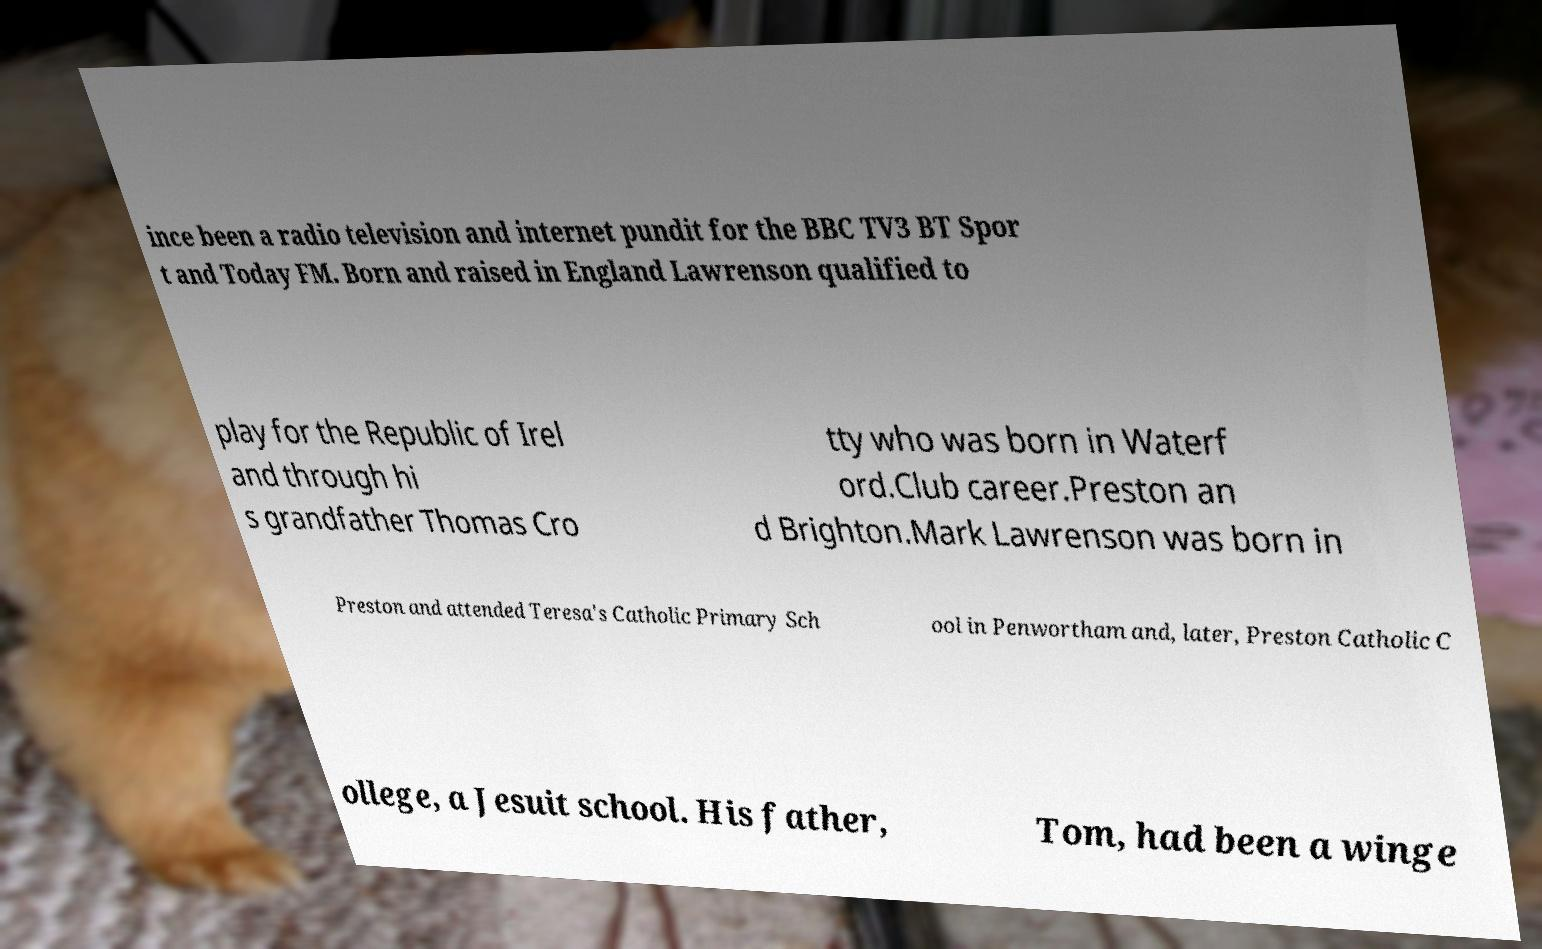I need the written content from this picture converted into text. Can you do that? ince been a radio television and internet pundit for the BBC TV3 BT Spor t and Today FM. Born and raised in England Lawrenson qualified to play for the Republic of Irel and through hi s grandfather Thomas Cro tty who was born in Waterf ord.Club career.Preston an d Brighton.Mark Lawrenson was born in Preston and attended Teresa's Catholic Primary Sch ool in Penwortham and, later, Preston Catholic C ollege, a Jesuit school. His father, Tom, had been a winge 